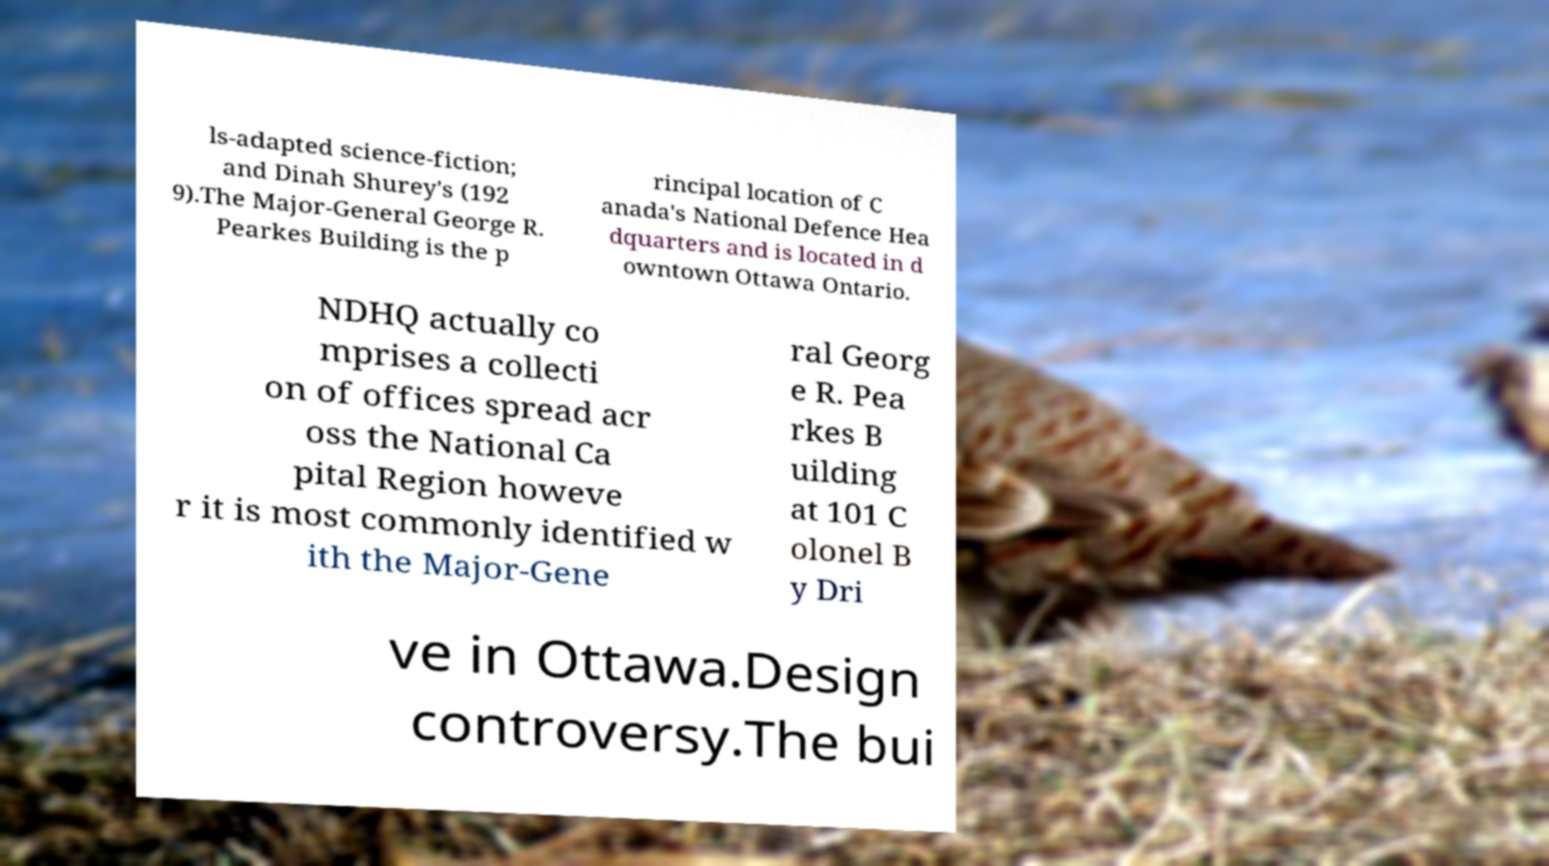There's text embedded in this image that I need extracted. Can you transcribe it verbatim? ls-adapted science-fiction; and Dinah Shurey's (192 9).The Major-General George R. Pearkes Building is the p rincipal location of C anada's National Defence Hea dquarters and is located in d owntown Ottawa Ontario. NDHQ actually co mprises a collecti on of offices spread acr oss the National Ca pital Region howeve r it is most commonly identified w ith the Major-Gene ral Georg e R. Pea rkes B uilding at 101 C olonel B y Dri ve in Ottawa.Design controversy.The bui 